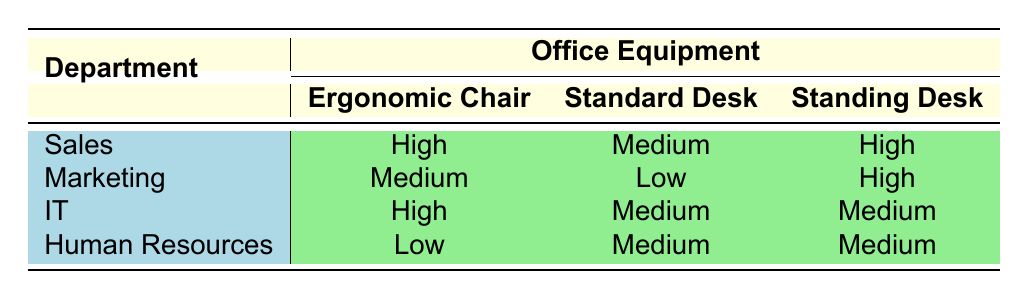What is the productivity level for the Sales department when using an Ergonomic Chair? By looking at the row corresponding to the Sales department and finding the Ergonomic Chair column, we see that the productivity level is High.
Answer: High Which department has the lowest productivity level when using Standard Desks? In the table, the Human Resources department shows a Medium productivity level for Standard Desks, while the Marketing department shows a Low productivity level. Therefore, Marketing has the lowest productivity level in this category.
Answer: Marketing How many departments report a High productivity level with Standing Desks? We need to check each department under the Standing Desk column. The Sales department and the Marketing department both report High productivity levels. Thus, there are two departments with High productivity levels for Standing Desks: Sales and Marketing.
Answer: 2 Is it true that the IT department has a higher productivity level with Ergonomic Chairs than with Standard Desks? Comparing the IT department's productivity level, we see that it is High for Ergonomic Chairs and Medium for Standard Desks. Therefore, the statement is true.
Answer: Yes What is the average productivity level for the Marketing department? The Marketing department has a Medium productivity level for Ergonomic Chairs, a Low level for Standard Desks, and a High level for Standing Desks. We can represent these levels numerically (High = 3, Medium = 2, Low = 1) and calculate the average: (3 + 2 + 1) / 3 = 2. The average productivity level corresponds to Medium.
Answer: Medium What is the productivity level for Human Resources when using Standing Desks? Checking the Human Resources row under the Standing Desk column shows a Medium productivity level.
Answer: Medium Which department performs equally well with both Standard Desks and Standing Desks? Looking at the table, the IT department shows Medium productivity levels for both Standard Desks and Standing Desks, implying they perform equally well with both kinds of equipment.
Answer: IT How many departments use Ergonomic Chairs with a High productivity level? Examining the Ergonomic Chair column, we find that the Sales department and the IT department both report High productivity levels. Thus, two departments use Ergonomic Chairs with High productivity levels.
Answer: 2 